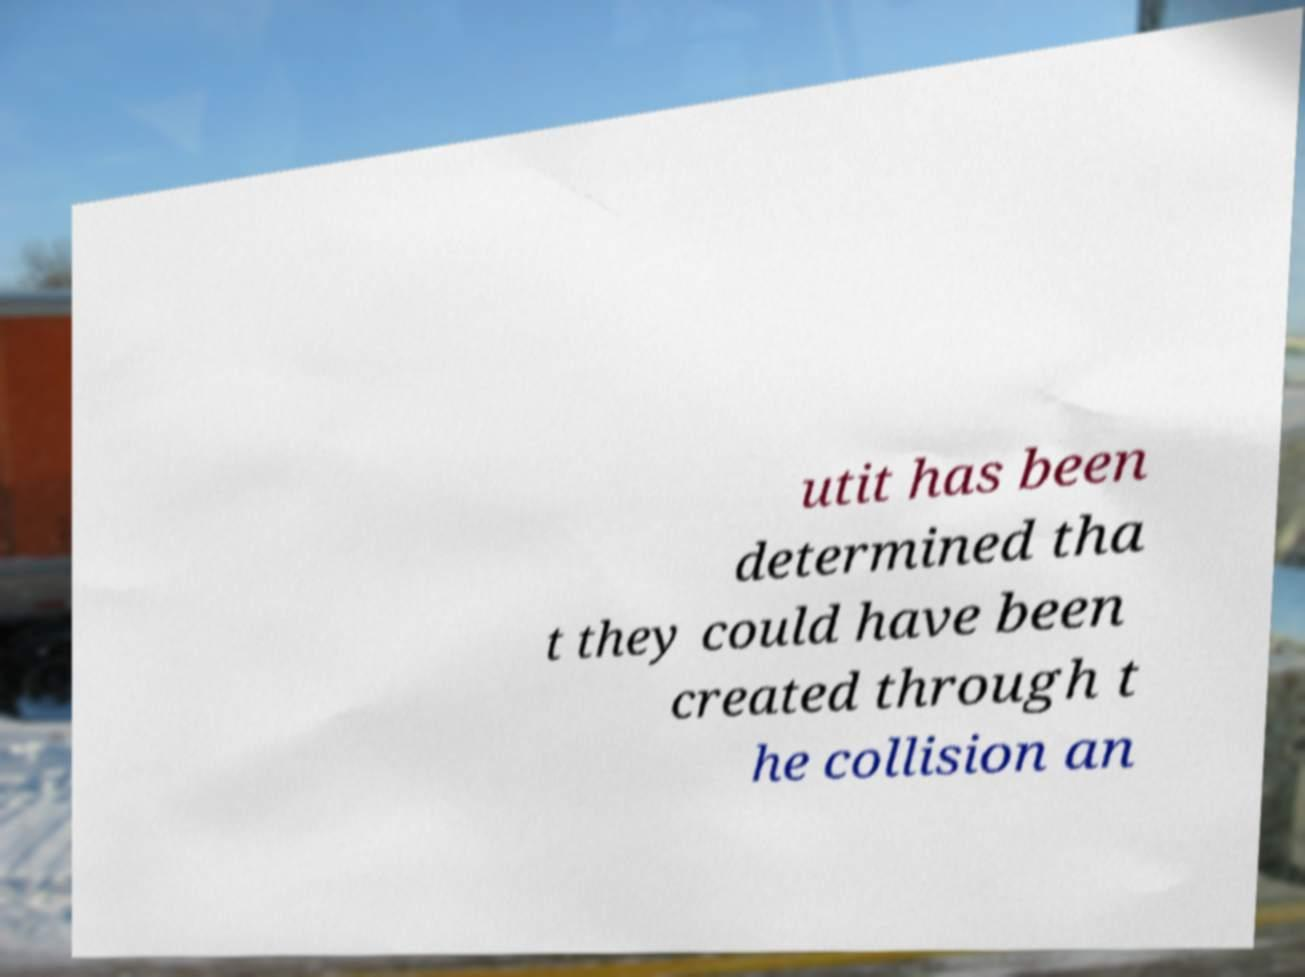There's text embedded in this image that I need extracted. Can you transcribe it verbatim? utit has been determined tha t they could have been created through t he collision an 